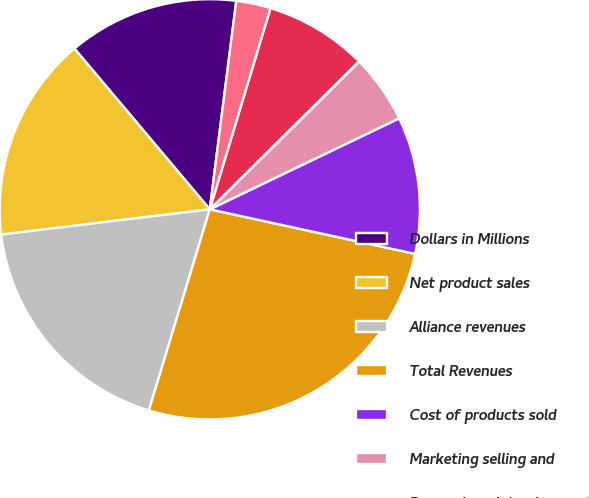Convert chart. <chart><loc_0><loc_0><loc_500><loc_500><pie_chart><fcel>Dollars in Millions<fcel>Net product sales<fcel>Alliance revenues<fcel>Total Revenues<fcel>Cost of products sold<fcel>Marketing selling and<fcel>Research and development<fcel>Other (income)/expense<fcel>Noncontrolling interest pretax<nl><fcel>13.15%<fcel>15.78%<fcel>18.4%<fcel>26.28%<fcel>10.53%<fcel>5.28%<fcel>0.03%<fcel>7.9%<fcel>2.65%<nl></chart> 